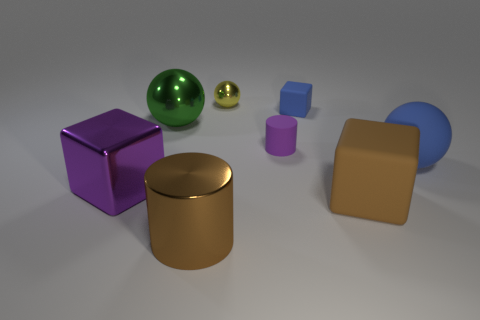What could be the purpose of having these objects in this arrangement? The purpose of this arrangement could be multiple: it could serve as a rendering test for a 3D artist to demonstrate material textures, lighting effects, and rendering capabilities; as part of a visual learning tool for educational purposes to teach about geometry and perspective; or even as an artistic expression to create a visually pleasing balance of forms and colors. 